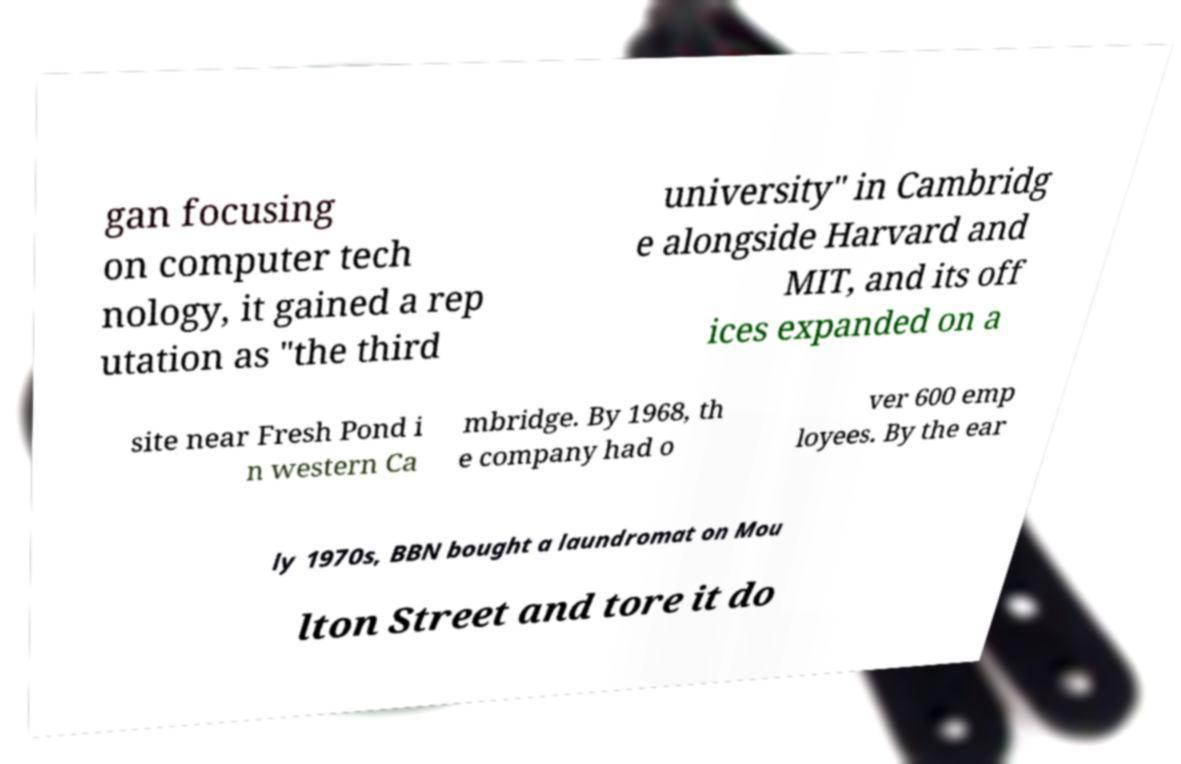Please identify and transcribe the text found in this image. gan focusing on computer tech nology, it gained a rep utation as "the third university" in Cambridg e alongside Harvard and MIT, and its off ices expanded on a site near Fresh Pond i n western Ca mbridge. By 1968, th e company had o ver 600 emp loyees. By the ear ly 1970s, BBN bought a laundromat on Mou lton Street and tore it do 